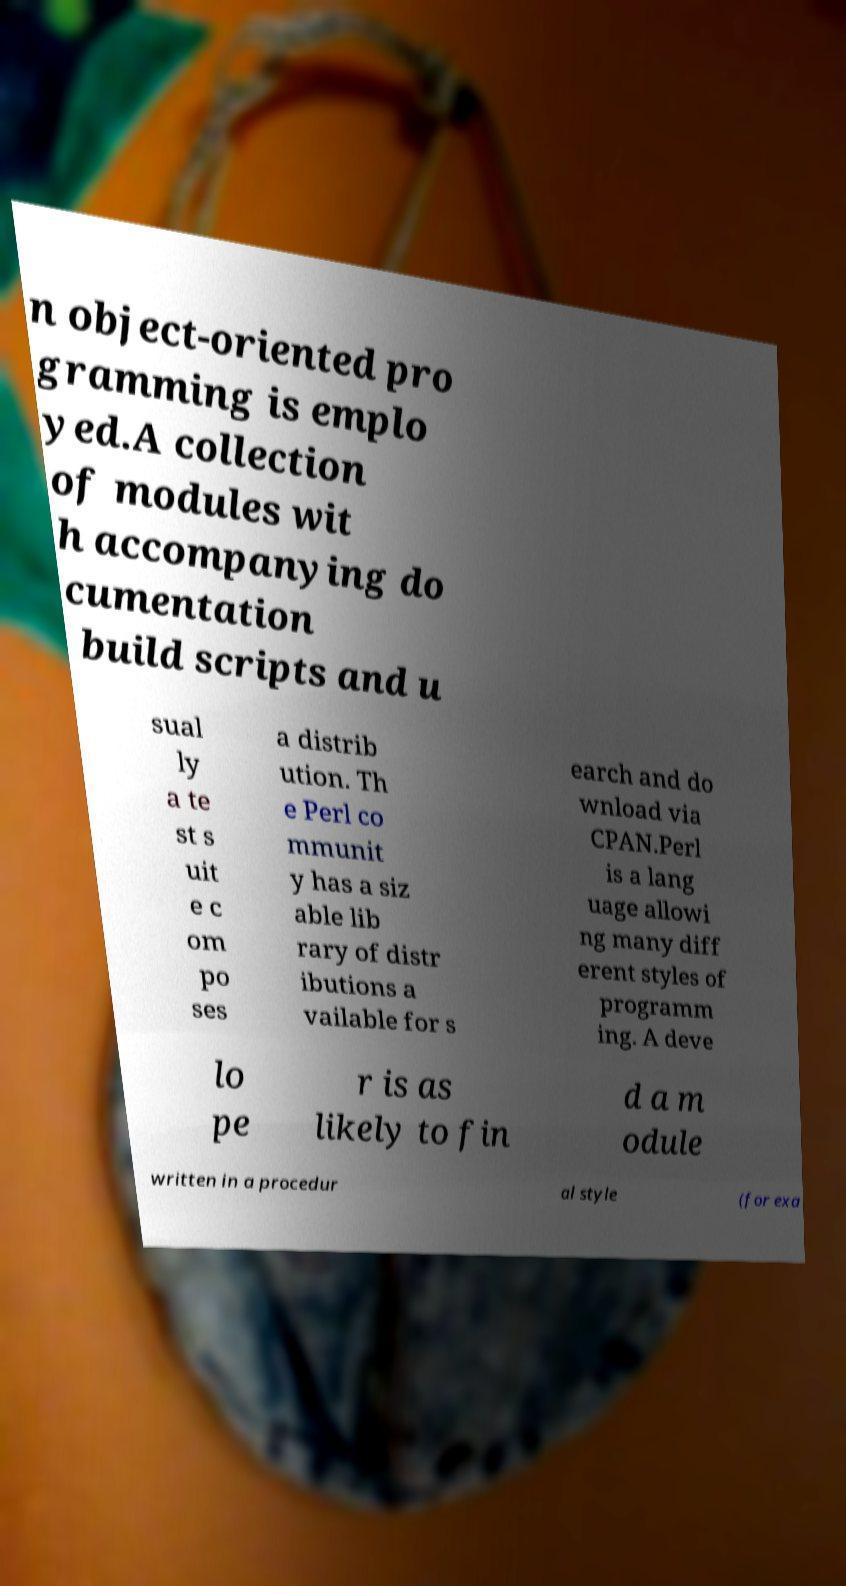I need the written content from this picture converted into text. Can you do that? n object-oriented pro gramming is emplo yed.A collection of modules wit h accompanying do cumentation build scripts and u sual ly a te st s uit e c om po ses a distrib ution. Th e Perl co mmunit y has a siz able lib rary of distr ibutions a vailable for s earch and do wnload via CPAN.Perl is a lang uage allowi ng many diff erent styles of programm ing. A deve lo pe r is as likely to fin d a m odule written in a procedur al style (for exa 